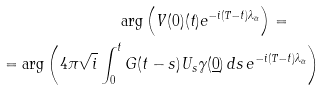<formula> <loc_0><loc_0><loc_500><loc_500>\arg \left ( V ( 0 ) ( t ) e ^ { - i ( T - t ) \lambda _ { \bar { \alpha } } } \right ) = \quad \\ = \arg \left ( 4 \pi \sqrt { i } \int _ { 0 } ^ { t } G ( t - s ) U _ { s } \gamma ( \underline { 0 } ) \, d s \, e ^ { - i ( T - t ) \lambda _ { \bar { \alpha } } } \right )</formula> 